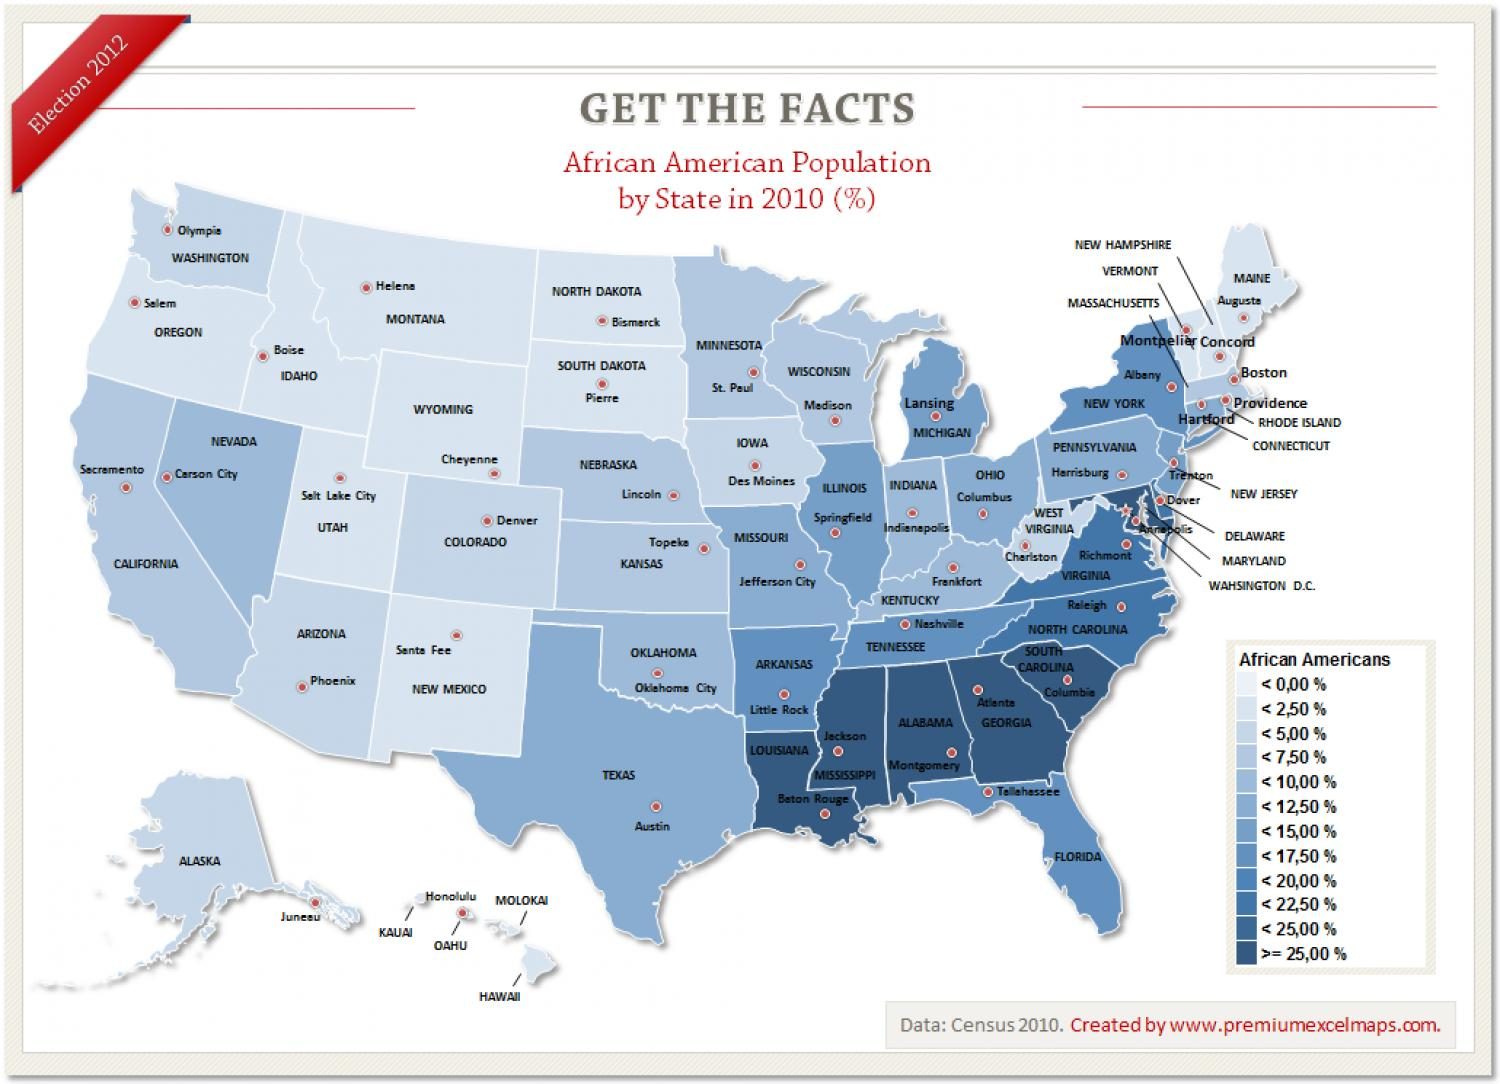Draw attention to some important aspects in this diagram. The infographic contains 12 groups of African Americans mentioned. 